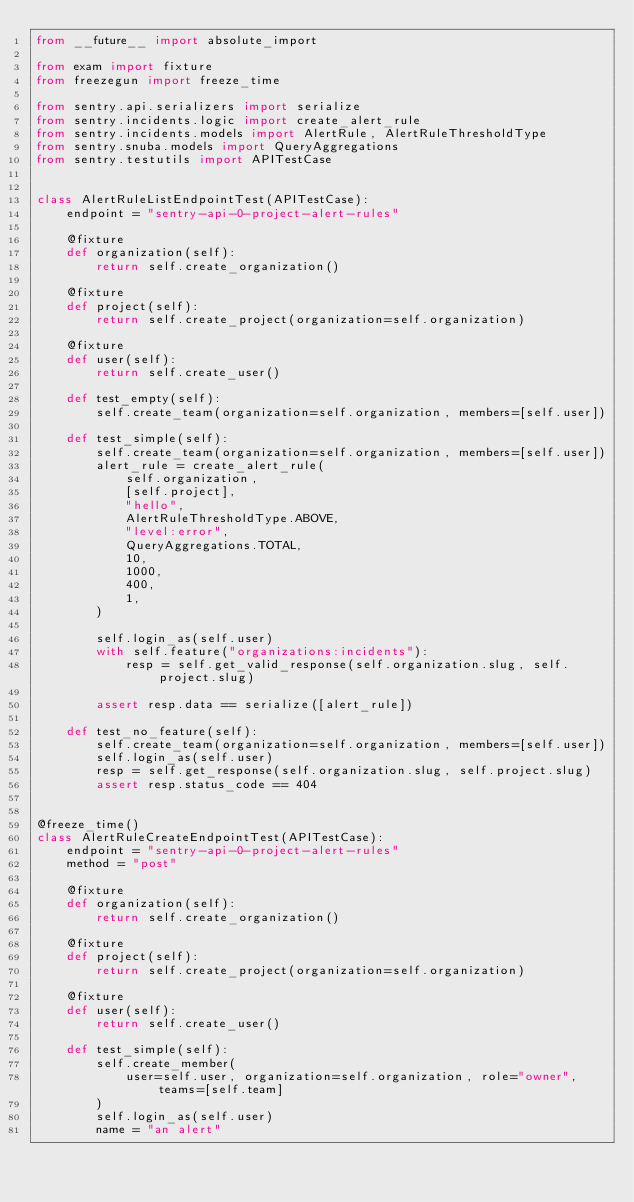Convert code to text. <code><loc_0><loc_0><loc_500><loc_500><_Python_>from __future__ import absolute_import

from exam import fixture
from freezegun import freeze_time

from sentry.api.serializers import serialize
from sentry.incidents.logic import create_alert_rule
from sentry.incidents.models import AlertRule, AlertRuleThresholdType
from sentry.snuba.models import QueryAggregations
from sentry.testutils import APITestCase


class AlertRuleListEndpointTest(APITestCase):
    endpoint = "sentry-api-0-project-alert-rules"

    @fixture
    def organization(self):
        return self.create_organization()

    @fixture
    def project(self):
        return self.create_project(organization=self.organization)

    @fixture
    def user(self):
        return self.create_user()

    def test_empty(self):
        self.create_team(organization=self.organization, members=[self.user])

    def test_simple(self):
        self.create_team(organization=self.organization, members=[self.user])
        alert_rule = create_alert_rule(
            self.organization,
            [self.project],
            "hello",
            AlertRuleThresholdType.ABOVE,
            "level:error",
            QueryAggregations.TOTAL,
            10,
            1000,
            400,
            1,
        )

        self.login_as(self.user)
        with self.feature("organizations:incidents"):
            resp = self.get_valid_response(self.organization.slug, self.project.slug)

        assert resp.data == serialize([alert_rule])

    def test_no_feature(self):
        self.create_team(organization=self.organization, members=[self.user])
        self.login_as(self.user)
        resp = self.get_response(self.organization.slug, self.project.slug)
        assert resp.status_code == 404


@freeze_time()
class AlertRuleCreateEndpointTest(APITestCase):
    endpoint = "sentry-api-0-project-alert-rules"
    method = "post"

    @fixture
    def organization(self):
        return self.create_organization()

    @fixture
    def project(self):
        return self.create_project(organization=self.organization)

    @fixture
    def user(self):
        return self.create_user()

    def test_simple(self):
        self.create_member(
            user=self.user, organization=self.organization, role="owner", teams=[self.team]
        )
        self.login_as(self.user)
        name = "an alert"</code> 